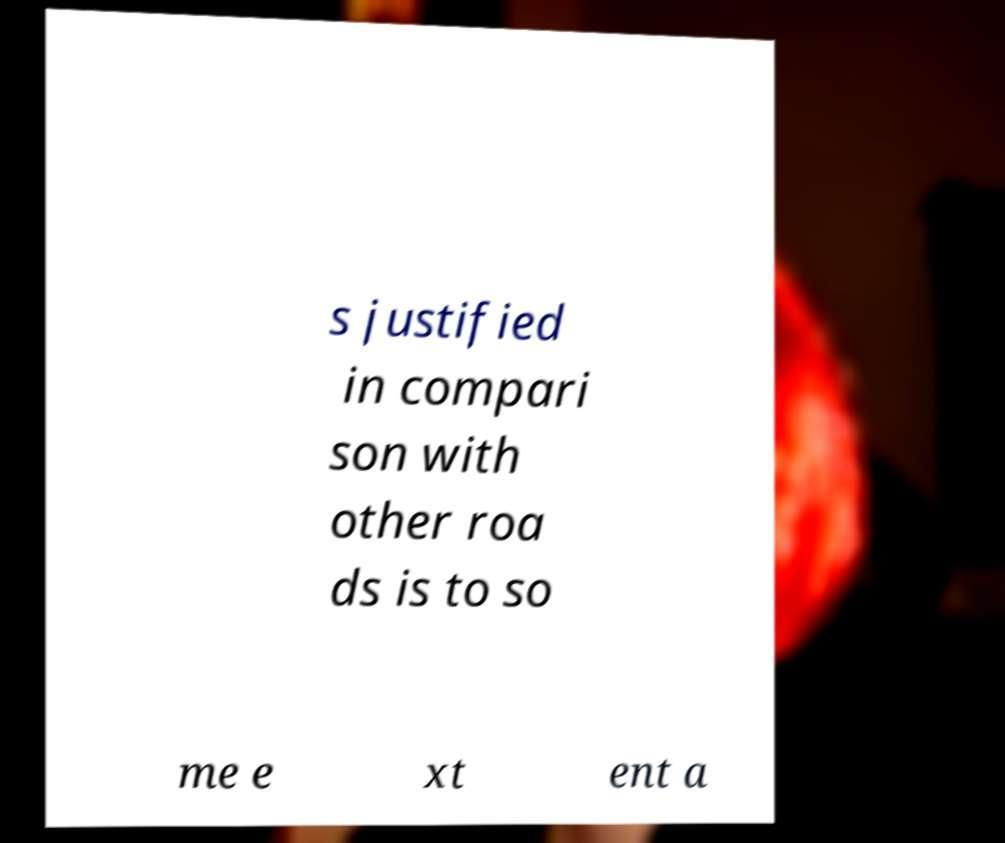Could you assist in decoding the text presented in this image and type it out clearly? s justified in compari son with other roa ds is to so me e xt ent a 